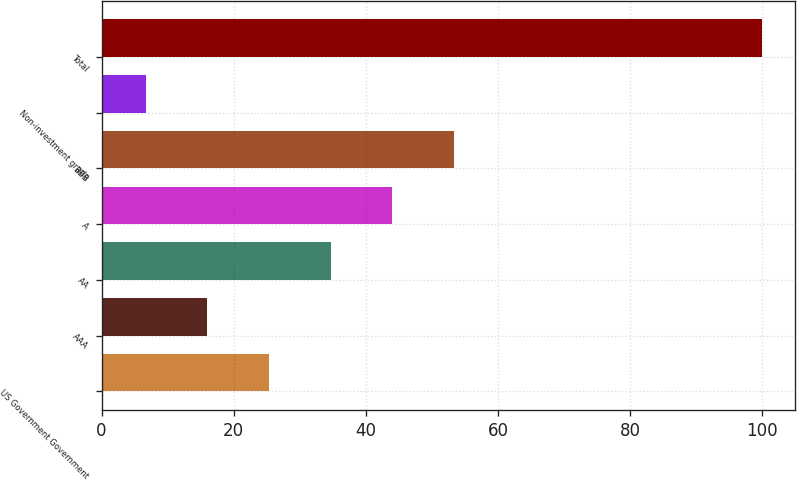Convert chart to OTSL. <chart><loc_0><loc_0><loc_500><loc_500><bar_chart><fcel>US Government Government<fcel>AAA<fcel>AA<fcel>A<fcel>BBB<fcel>Non-investment grade<fcel>Total<nl><fcel>25.36<fcel>16.03<fcel>34.69<fcel>44.02<fcel>53.35<fcel>6.7<fcel>100<nl></chart> 